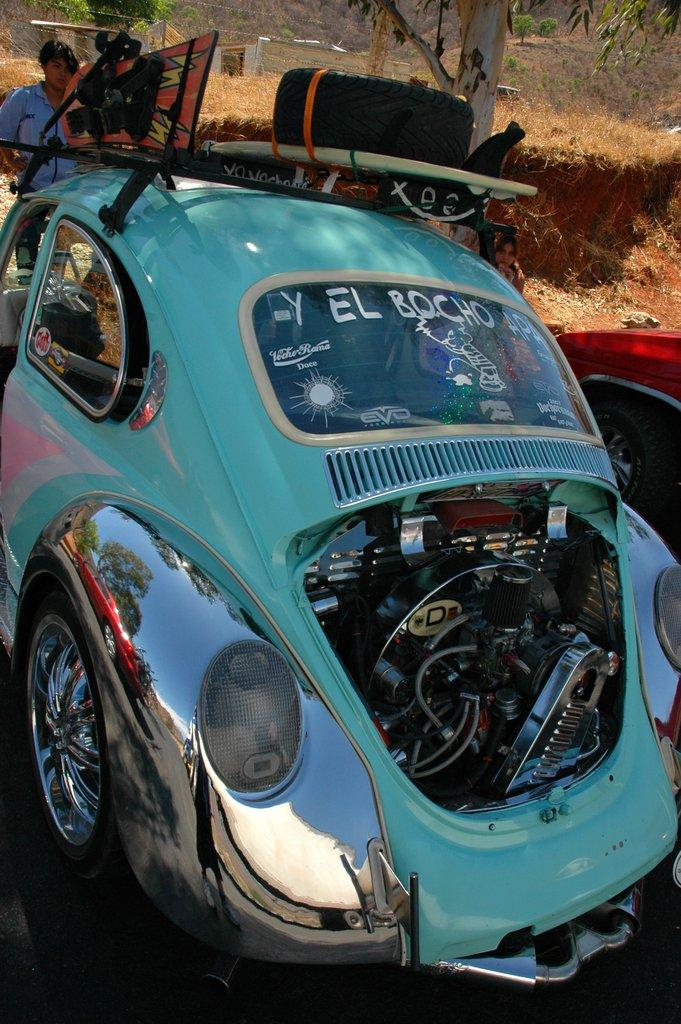What is the main subject of the image? There is a car in the image. Are there any additional objects or features on the car? Yes, there are objects on the car. Can you describe the person in the image? There is a person standing in the image. What type of natural environment is visible in the image? There is a tree and grass in the image. How many cars can be seen in the image? There is a red car that appears to be partially visible or truncated in the image, in addition to the main car. What type of shoe can be seen hanging from the tree in the image? There is no shoe hanging from the tree in the image; only a tree and grass are present. What scientific experiment is being conducted in the image? There is no scientific experiment depicted in the image; it features a car, objects on the car, a person, a tree, and grass. 